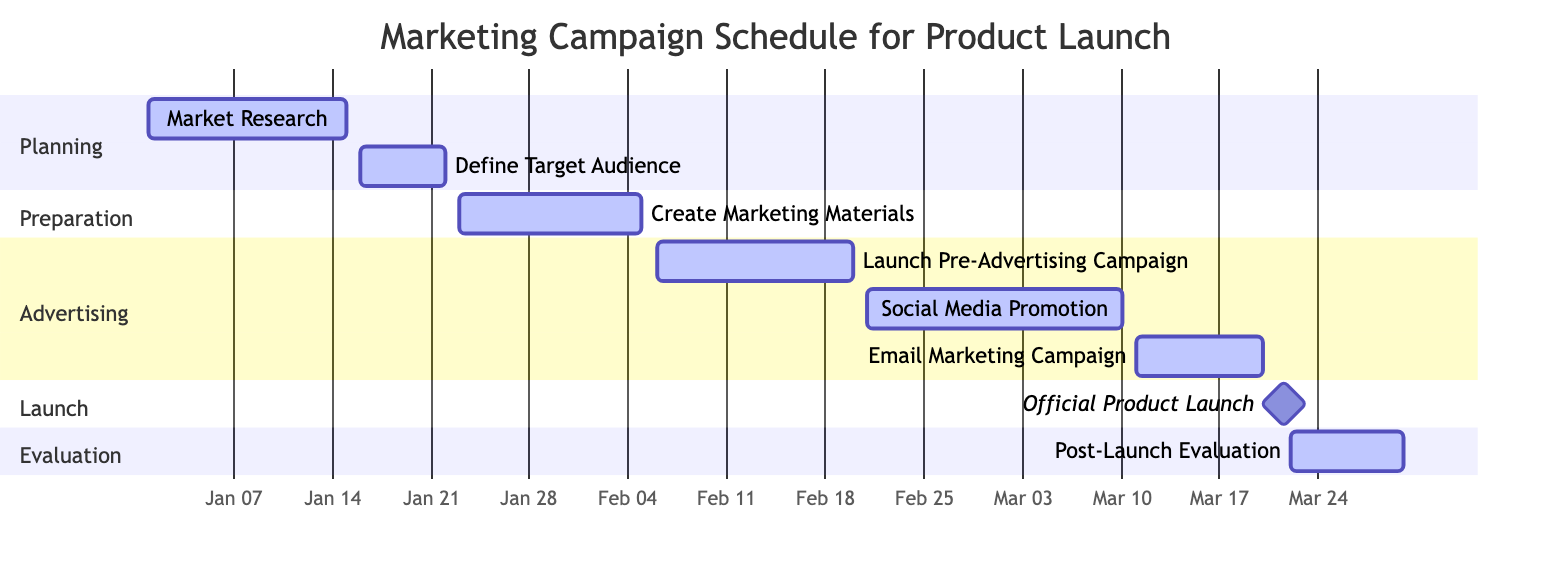What is the total number of tasks in the Gantt chart? The Gantt chart displays eight different tasks related to the marketing campaign, counting all tasks listed from planning to evaluation.
Answer: 8 Which task starts on February 21, 2024? Referring to the timeline in the Gantt chart, the task that begins on February 21 is "Social Media Promotion."
Answer: Social Media Promotion What is the start date of the "Official Product Launch"? The "Official Product Launch" is marked as a milestone in the Gantt chart and is scheduled to start on March 21, 2024.
Answer: March 21, 2024 During which month does the "Post-Launch Evaluation" occur? Observing the duration provided in the chart, the "Post-Launch Evaluation" runs from March 22 to March 30, 2024, thus it takes place in March.
Answer: March How many tasks are scheduled for the Advertising phase? The Advertising section in the Gantt chart consists of three tasks: "Launch Pre-Advertising Campaign," "Social Media Promotion," and "Email Marketing Campaign."
Answer: 3 Which task overlaps with "Create Marketing Materials"? The "Launch Pre-Advertising Campaign" starts on February 6, 2024, and overlaps with "Create Marketing Materials," whose end date is February 5, indicating they occur in successive days.
Answer: Launch Pre-Advertising Campaign What is the duration of "Email Marketing Campaign"? The "Email Marketing Campaign" runs from March 11 to March 20, 2024, which spans a total of ten days.
Answer: 10 days Is the "Market Research" task active or a milestone? The "Market Research" task is listed as active, indicating it is currently in progress, rather than being a milestone.
Answer: active 